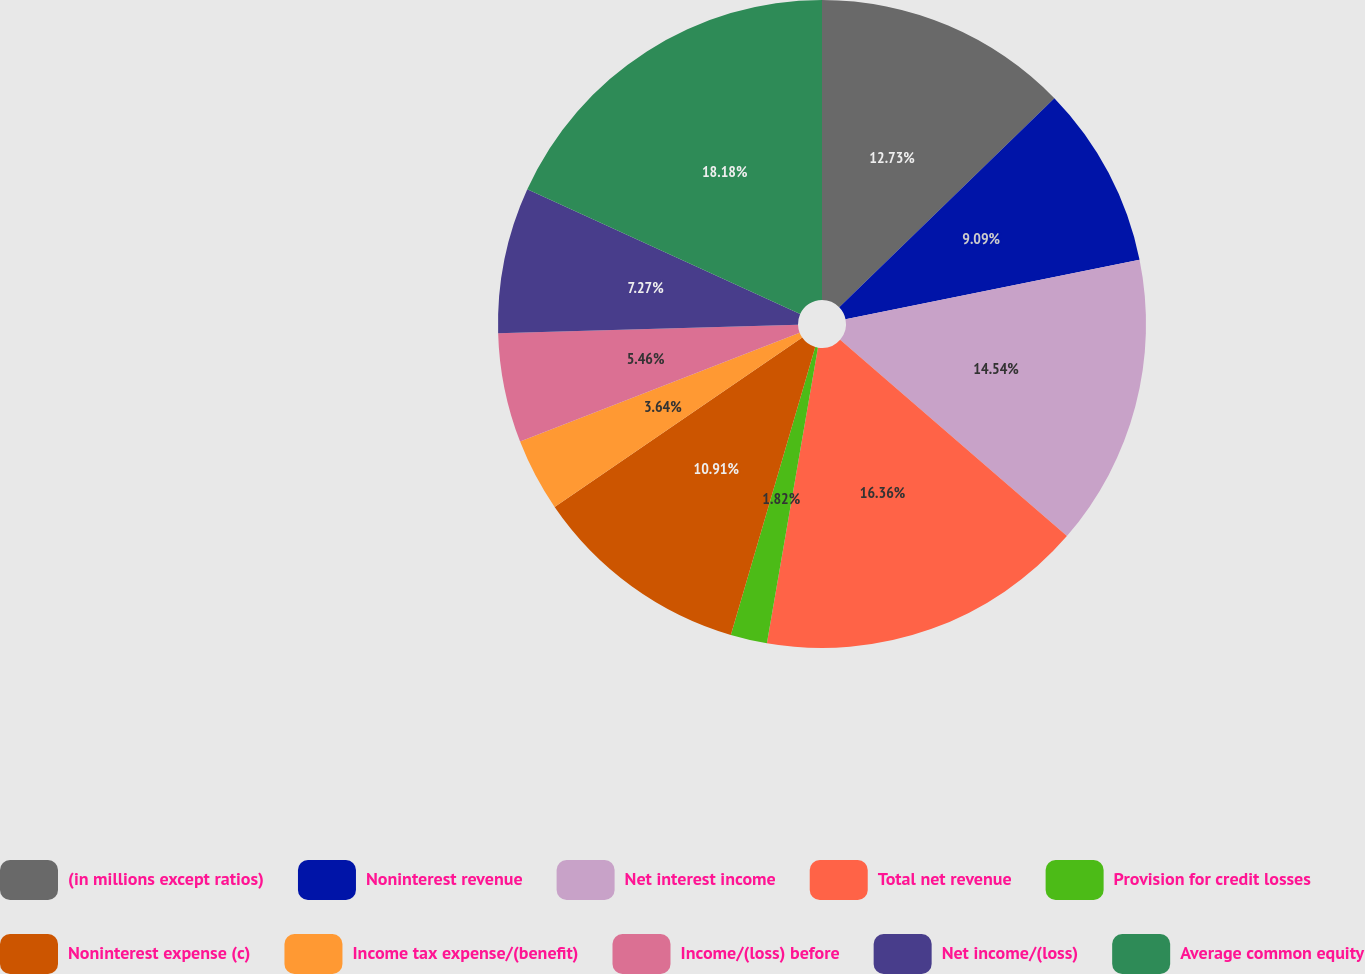Convert chart to OTSL. <chart><loc_0><loc_0><loc_500><loc_500><pie_chart><fcel>(in millions except ratios)<fcel>Noninterest revenue<fcel>Net interest income<fcel>Total net revenue<fcel>Provision for credit losses<fcel>Noninterest expense (c)<fcel>Income tax expense/(benefit)<fcel>Income/(loss) before<fcel>Net income/(loss)<fcel>Average common equity<nl><fcel>12.73%<fcel>9.09%<fcel>14.54%<fcel>16.36%<fcel>1.82%<fcel>10.91%<fcel>3.64%<fcel>5.46%<fcel>7.27%<fcel>18.18%<nl></chart> 